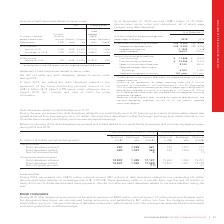According to Rogers Communications's financial document, What percentage of US dollar-denominated senior notes and debentures are hedged for accounting and economic purposes? According to the financial document, 100%. The relevant text states: "31, 2019 and December 31, 2018, RCI accounted for 100% of its debt derivatives related to senior notes as hedges against designated US dollar-denominated d 31, 2019 and December 31, 2018, RCI accounte..." Also, What components are included under borrowings? long-term debt, including the impact of debt derivatives, and short-term borrowings associated with our US CP and accounts receivable securitization programs.. The document states: "3 Borrowings include long-term debt, including the impact of debt derivatives, and short-term borrowings associated with our US CP and accounts receiv..." Also, What was the hedged exchange rate in 2019? According to the financial document, 1.1932. The relevant text states: "ivatives US$ 8,300 US$ 6,050 Hedged exchange rate 1.1932 1.1438 Percent hedged 2 100.0% 100.0%..." Also, can you calculate: What was the increase / (decrease) in US dollar-denominated long-term debt from 2018 to 2019? Based on the calculation: 8,300 - 6,050, the result is 2250 (in millions). This is based on the information: "dollar-denominated long-term debt 1 US$ 8,300 US$ 6,050 Hedged with debt derivatives US$ 8,300 US$ 6,050 Hedged exchange rate 1.1932 1.1438 Percent hedged US dollar-denominated long-term debt 1 US$ 8,..." The key data points involved are: 6,050, 8,300. Also, can you calculate: What was the average Hedged with debt derivatives? To answer this question, I need to perform calculations using the financial data. The calculation is: (8,300 + 6,050) / 2, which equals 7175 (in millions). This is based on the information: "dollar-denominated long-term debt 1 US$ 8,300 US$ 6,050 Hedged with debt derivatives US$ 8,300 US$ 6,050 Hedged exchange rate 1.1932 1.1438 Percent hedged US dollar-denominated long-term debt 1 US$ 8,..." The key data points involved are: 6,050, 8,300. Also, can you calculate: What was the increase / (decrease) in Total borrowings from 2018 to 2019? Based on the calculation: 17,496 - 15,320, the result is 2176 (in millions). This is based on the information: "Total borrowings $ 17,496 $ 15,320 Total borrowings at fixed rates $ 15,254 $ 13,070 Percent of borrowings at fixed rates 87.2% 85.3% Total borrowings $ 17,496 $ 15,320 Total borrowings at fixed rates..." The key data points involved are: 15,320, 17,496. 